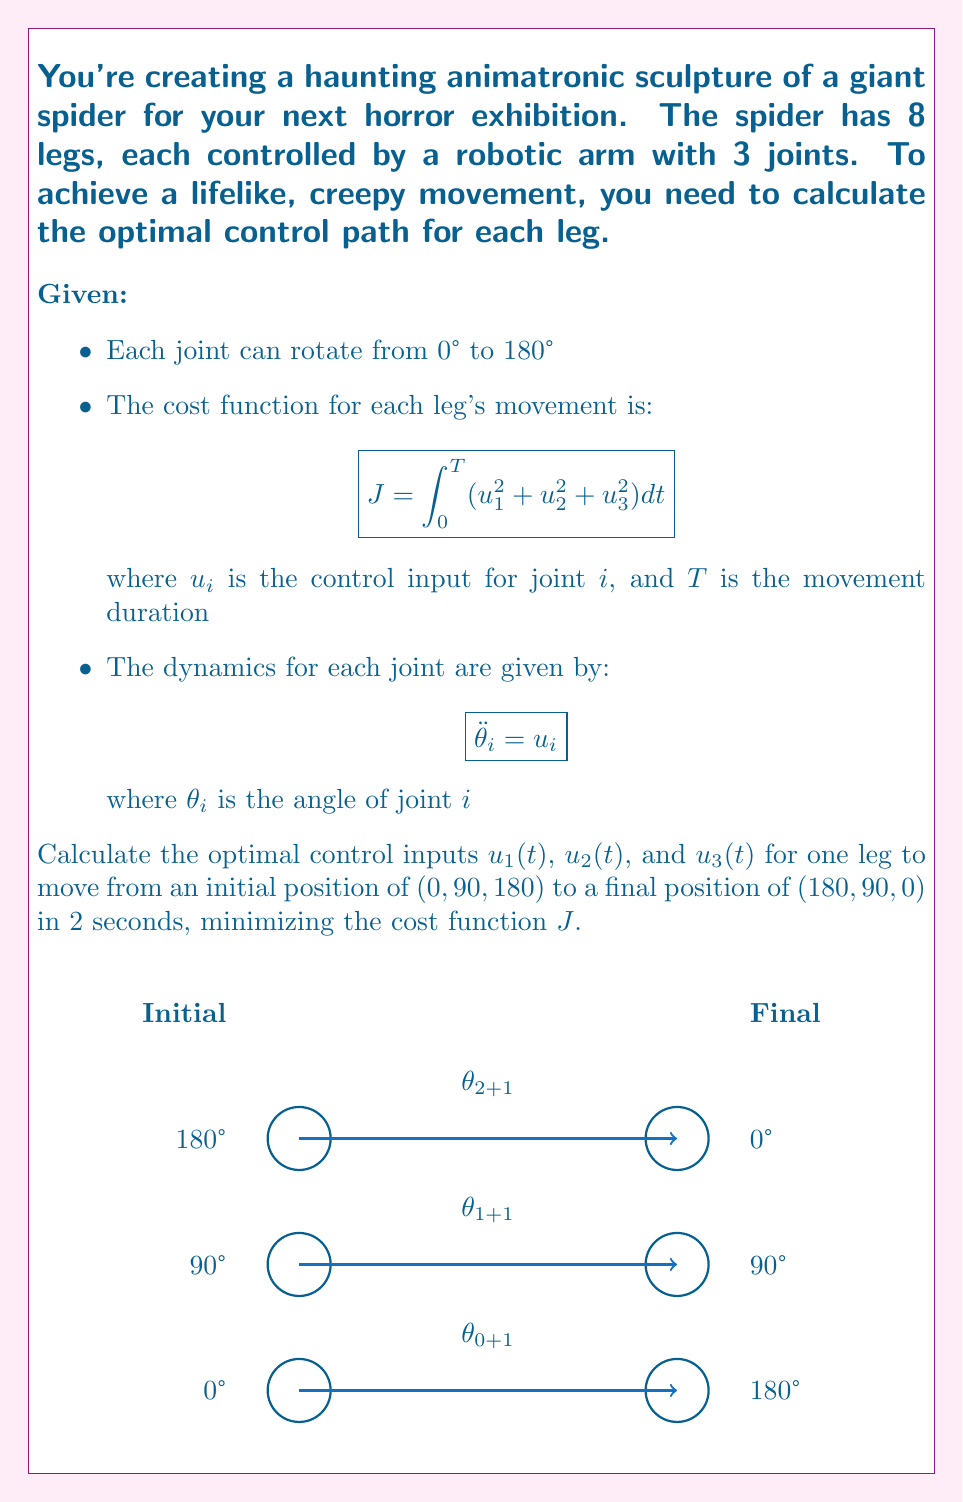Help me with this question. To solve this optimal control problem, we'll use Pontryagin's Maximum Principle:

1) Define the Hamiltonian:
   $$H = u_1^2 + u_2^2 + u_3^2 + \lambda_1 \omega_1 + \lambda_2 \omega_2 + \lambda_3 \omega_3 + \mu_1 u_1 + \mu_2 u_2 + \mu_3 u_3$$
   where $\omega_i = \dot{\theta}_i$ and $\lambda_i$, $\mu_i$ are costate variables.

2) Derive the costate equations:
   $$\dot{\lambda}_i = -\frac{\partial H}{\partial \theta_i} = 0$$
   $$\dot{\mu}_i = -\frac{\partial H}{\partial \omega_i} = -\lambda_i$$

3) Optimal control:
   $$\frac{\partial H}{\partial u_i} = 2u_i + \mu_i = 0$$
   $$u_i = -\frac{1}{2}\mu_i$$

4) Solve the differential equations:
   $$\lambda_i = c_i \text{ (constant)}$$
   $$\mu_i = -c_i t + d_i$$
   $$u_i = \frac{1}{2}c_i t - \frac{1}{2}d_i$$
   $$\omega_i = \frac{1}{4}c_i t^2 - \frac{1}{2}d_i t + e_i$$
   $$\theta_i = \frac{1}{12}c_i t^3 - \frac{1}{4}d_i t^2 + e_i t + f_i$$

5) Apply boundary conditions:
   For $\theta_1$: $\theta_1(0) = 0°$, $\theta_1(2) = 180°$
   For $\theta_2$: $\theta_2(0) = 90°$, $\theta_2(2) = 90°$
   For $\theta_3$: $\theta_3(0) = 180°$, $\theta_3(2) = 0°$

6) Solve for constants:
   For $\theta_1$: $c_1 = 405°$, $d_1 = 270°$, $e_1 = 0°$, $f_1 = 0°$
   For $\theta_2$: $c_2 = 0°$, $d_2 = 0°$, $e_2 = 0°$, $f_2 = 90°$
   For $\theta_3$: $c_3 = -405°$, $d_3 = -270°$, $e_3 = 0°$, $f_3 = 180°$

7) Optimal control inputs:
   $$u_1(t) = \frac{405°}{2}t - 135° = 202.5°t - 135°$$
   $$u_2(t) = 0°$$
   $$u_3(t) = -\frac{405°}{2}t + 135° = -202.5°t + 135°$$
Answer: $u_1(t) = 202.5°t - 135°$, $u_2(t) = 0°$, $u_3(t) = -202.5°t + 135°$ 